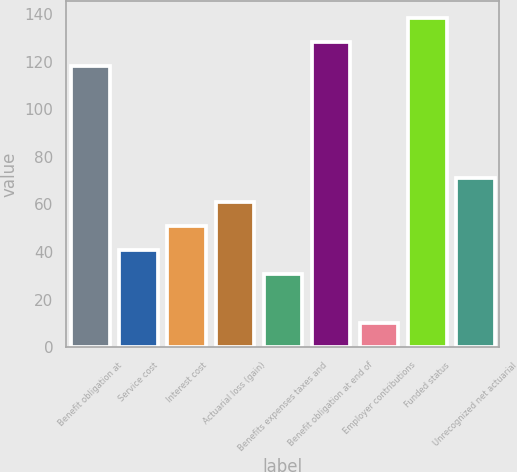Convert chart to OTSL. <chart><loc_0><loc_0><loc_500><loc_500><bar_chart><fcel>Benefit obligation at<fcel>Service cost<fcel>Interest cost<fcel>Actuarial loss (gain)<fcel>Benefits expenses taxes and<fcel>Benefit obligation at end of<fcel>Employer contributions<fcel>Funded status<fcel>Unrecognized net actuarial<nl><fcel>118.11<fcel>40.78<fcel>50.95<fcel>61.12<fcel>30.61<fcel>128.28<fcel>10.27<fcel>138.45<fcel>71.29<nl></chart> 